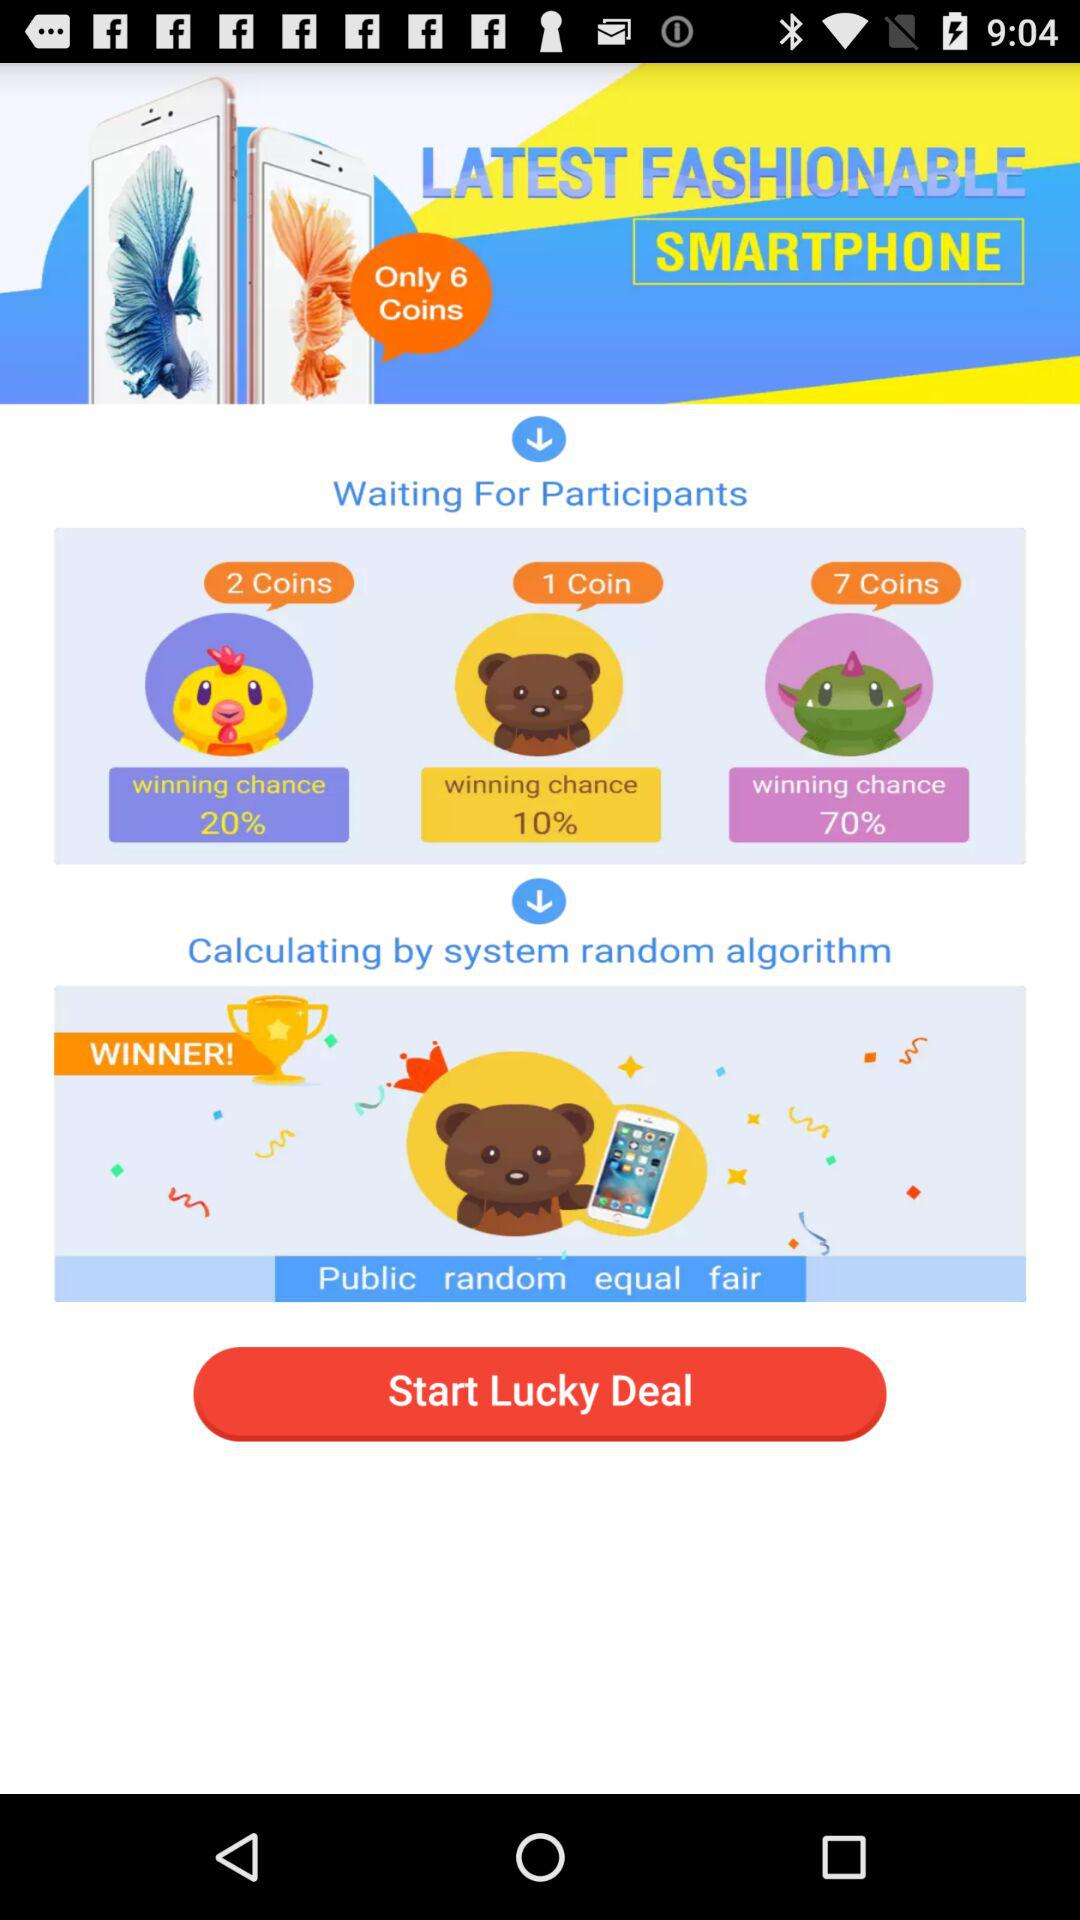What are the winning chance of yellow emojis?
When the provided information is insufficient, respond with <no answer>. <no answer> 